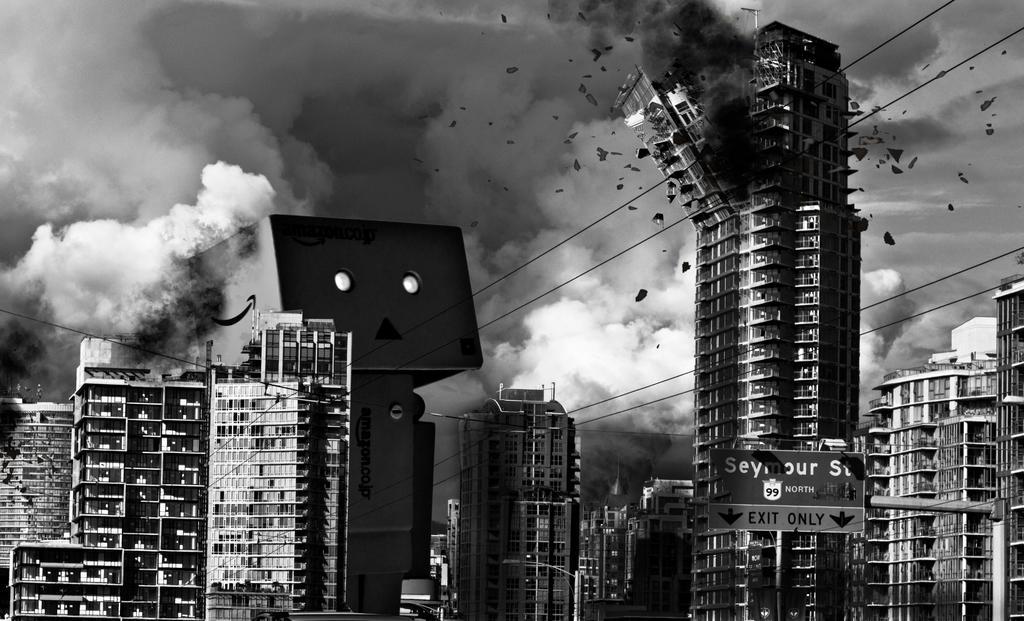How would you summarize this image in a sentence or two? In this picture we can see buildings, direction board, pole and in the background we can see smoke. 